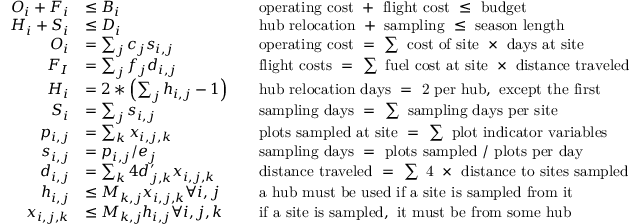<formula> <loc_0><loc_0><loc_500><loc_500>\begin{array} { r l r l } { O _ { i } + F _ { i } } & { \leq B _ { i } } & & { o p e r a t i n g \cos t + f l i g h t \cos t \leq b u d g e t } \\ { H _ { i } + S _ { i } } & { \leq D _ { i } } & & { h u b r e l o c a t i o n + s a m p l i n g \leq s e a s o n l e n g t h } \\ { O _ { i } } & { = \sum _ { j } c _ { j } s _ { i , j } } & & { o p e r a t i n g \cos t = \sum \cos t o f s i t e \times d a y s a t s i t e } \\ { F _ { I } } & { = \sum _ { j } f _ { j } d _ { i , j } } & & { f l i g h t \cos t s = \sum f u e l \cos t a t s i t e \times d i s t a n c e t r a v e l e d } \\ { H _ { i } } & { = 2 * \left ( \sum _ { j } h _ { i , j } - 1 \right ) } & & { h u b r e l o c a t i o n d a y s = 2 p e r h u b , e x c e p t t h e f i r s t } \\ { S _ { i } } & { = \sum _ { j } s _ { i , j } } & & { s a m p l i n g d a y s = \sum s a m p l i n g d a y s p e r s i t e } \\ { p _ { i , j } } & { = \sum _ { k } x _ { i , j , k } } & & { p l o t s s a m p l e d a t s i t e = \sum p l o t i n d i c a t o r v a r i a b l e s } \\ { s _ { i , j } } & { = p _ { i , j } / e _ { j } } & & { s a m p l i n g d a y s = p l o t s s a m p l e d / p l o t s p e r d a y } \\ { d _ { i , j } } & { = \sum _ { k } 4 d _ { j , k } ^ { \prime } x _ { i , j , k } } & & { d i s t a n c e t r a v e l e d = \sum 4 \times d i s t a n c e t o s i t e s s a m p l e d } \\ { h _ { i , j } } & { \leq M _ { k , j } x _ { i , j , k } \forall i , j } & & { a h u b m u s t b e u s e d i f a s i t e i s s a m p l e d f r o m i t } \\ { x _ { i , j , k } } & { \leq M _ { k , j } h _ { i , j } \forall i , j , k } & & { i f a s i t e i s s a m p l e d , i t m u s t b e f r o m s o m e h u b } \end{array}</formula> 